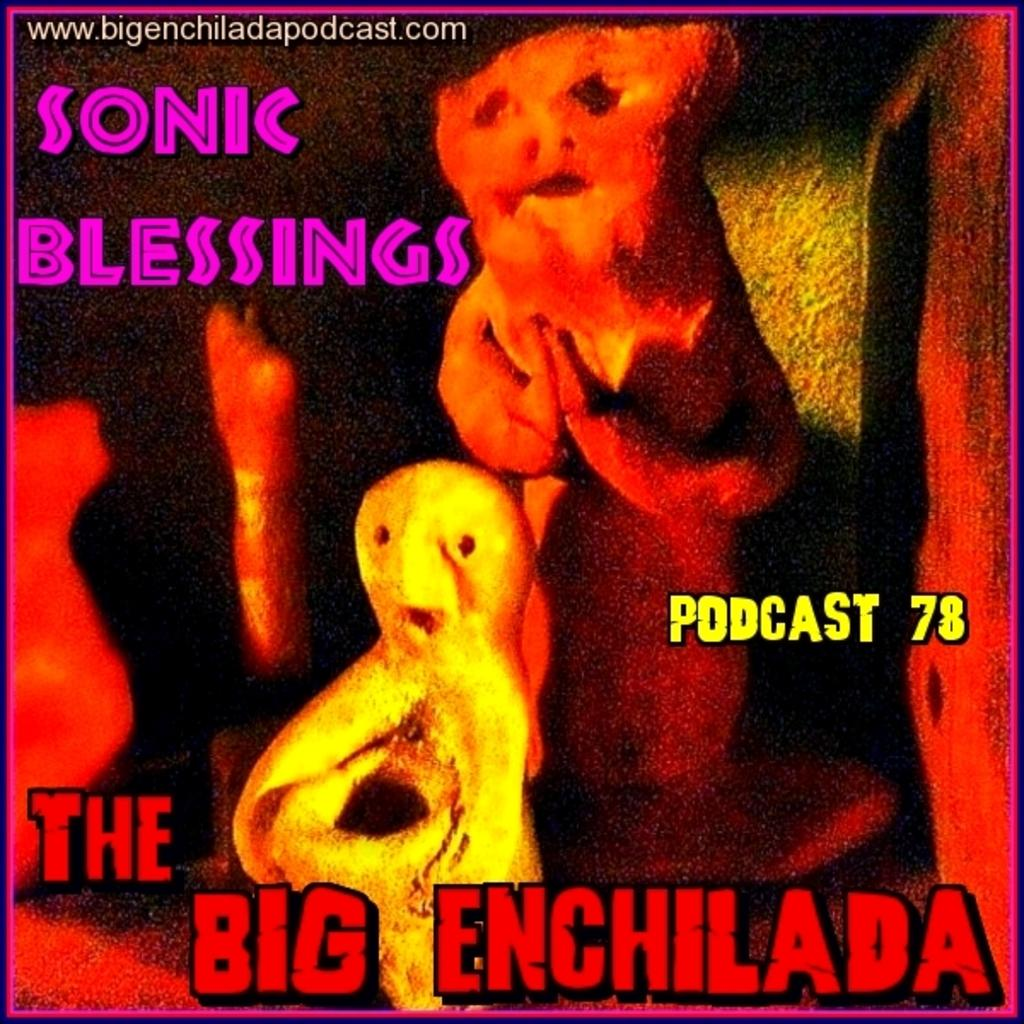<image>
Give a short and clear explanation of the subsequent image. An Advertisement for The Big Enchilada podcast 78 by Sonic Blessings. 